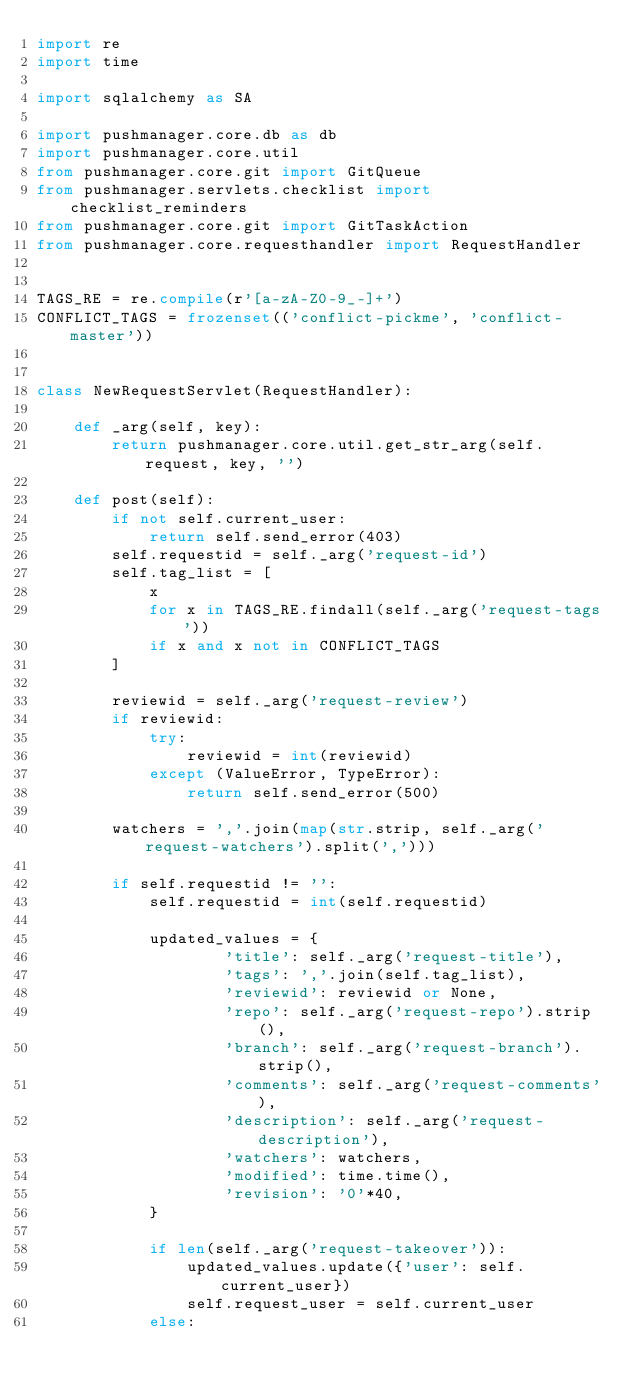Convert code to text. <code><loc_0><loc_0><loc_500><loc_500><_Python_>import re
import time

import sqlalchemy as SA

import pushmanager.core.db as db
import pushmanager.core.util
from pushmanager.core.git import GitQueue
from pushmanager.servlets.checklist import checklist_reminders
from pushmanager.core.git import GitTaskAction
from pushmanager.core.requesthandler import RequestHandler


TAGS_RE = re.compile(r'[a-zA-Z0-9_-]+')
CONFLICT_TAGS = frozenset(('conflict-pickme', 'conflict-master'))


class NewRequestServlet(RequestHandler):

    def _arg(self, key):
        return pushmanager.core.util.get_str_arg(self.request, key, '')

    def post(self):
        if not self.current_user:
            return self.send_error(403)
        self.requestid = self._arg('request-id')
        self.tag_list = [
            x
            for x in TAGS_RE.findall(self._arg('request-tags'))
            if x and x not in CONFLICT_TAGS
        ]

        reviewid = self._arg('request-review')
        if reviewid:
            try:
                reviewid = int(reviewid)
            except (ValueError, TypeError):
                return self.send_error(500)

        watchers = ','.join(map(str.strip, self._arg('request-watchers').split(',')))

        if self.requestid != '':
            self.requestid = int(self.requestid)

            updated_values = {
                    'title': self._arg('request-title'),
                    'tags': ','.join(self.tag_list),
                    'reviewid': reviewid or None,
                    'repo': self._arg('request-repo').strip(),
                    'branch': self._arg('request-branch').strip(),
                    'comments': self._arg('request-comments'),
                    'description': self._arg('request-description'),
                    'watchers': watchers,
                    'modified': time.time(),
                    'revision': '0'*40,
            }

            if len(self._arg('request-takeover')):
                updated_values.update({'user': self.current_user})
                self.request_user = self.current_user
            else:</code> 